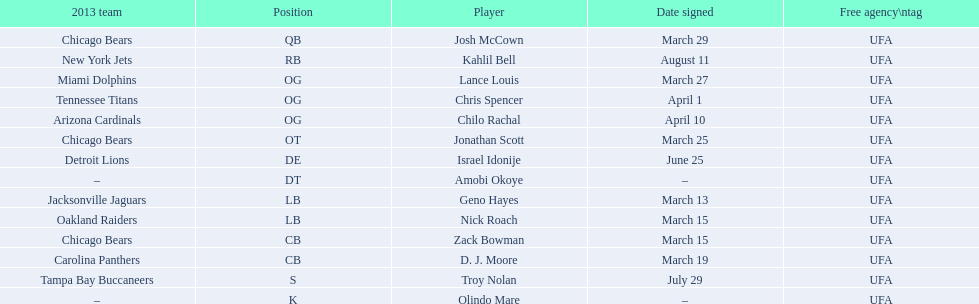Who are all of the players? Josh McCown, Kahlil Bell, Lance Louis, Chris Spencer, Chilo Rachal, Jonathan Scott, Israel Idonije, Amobi Okoye, Geno Hayes, Nick Roach, Zack Bowman, D. J. Moore, Troy Nolan, Olindo Mare. When were they signed? March 29, August 11, March 27, April 1, April 10, March 25, June 25, –, March 13, March 15, March 15, March 19, July 29, –. Along with nick roach, who else was signed on march 15? Zack Bowman. 